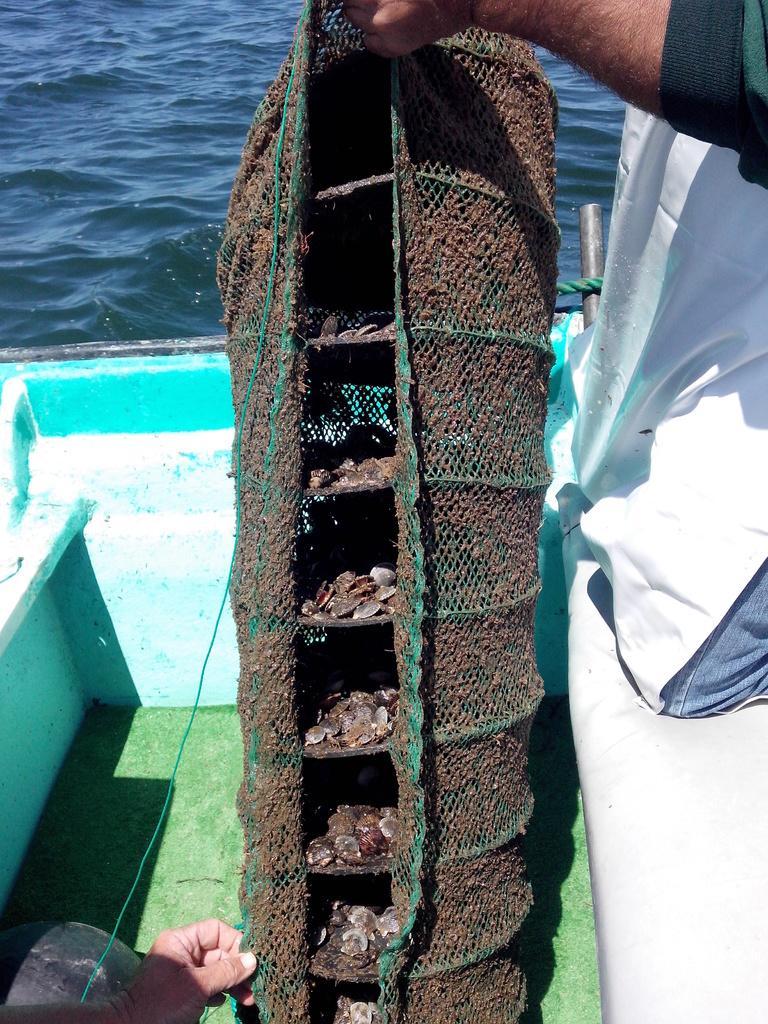Please provide a concise description of this image. In this image, we can see a hand holding shells container. There is an another hand in the bottom left of the image. There is a water at the top of the image. 